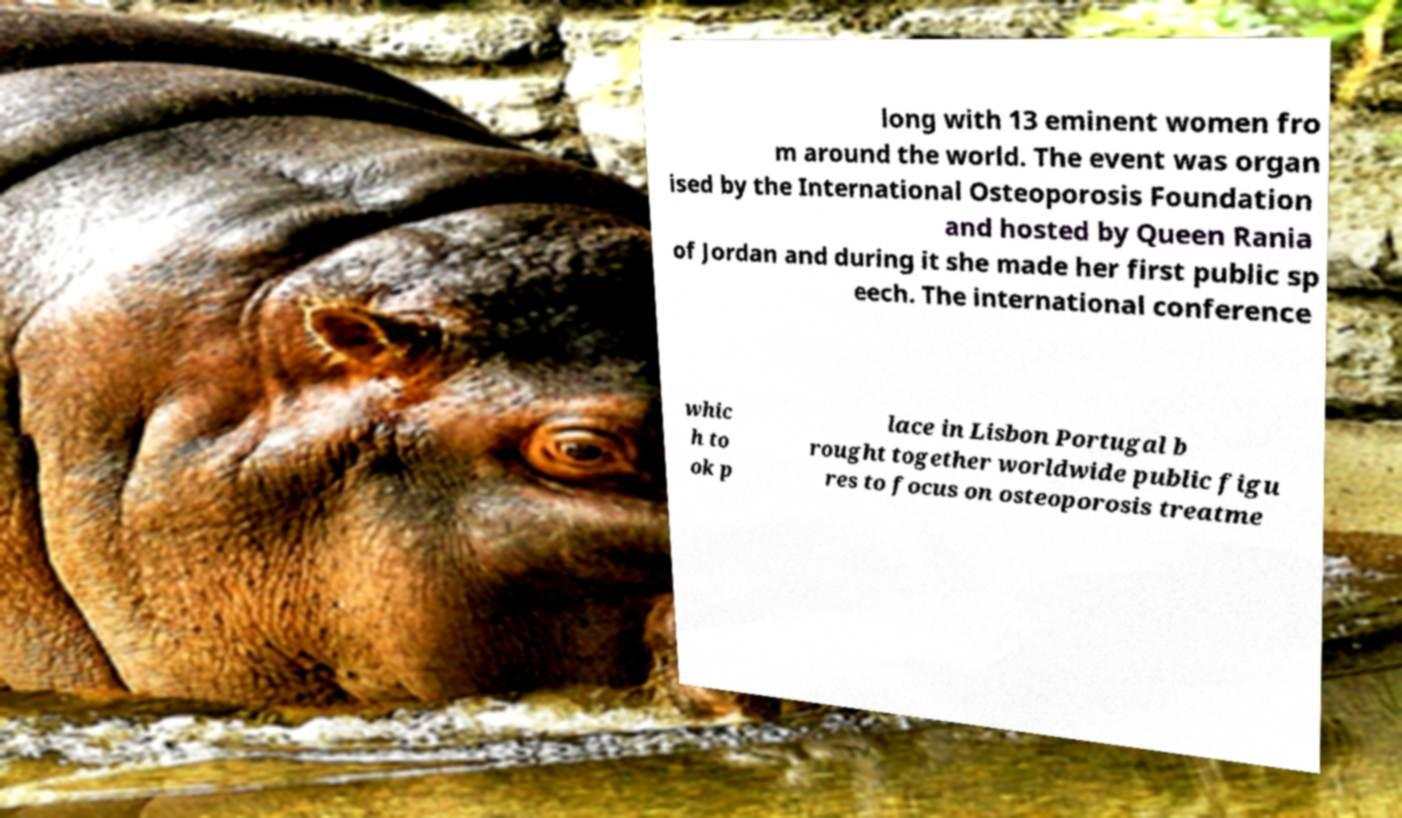Could you assist in decoding the text presented in this image and type it out clearly? long with 13 eminent women fro m around the world. The event was organ ised by the International Osteoporosis Foundation and hosted by Queen Rania of Jordan and during it she made her first public sp eech. The international conference whic h to ok p lace in Lisbon Portugal b rought together worldwide public figu res to focus on osteoporosis treatme 